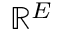<formula> <loc_0><loc_0><loc_500><loc_500>\mathbb { R } ^ { E }</formula> 